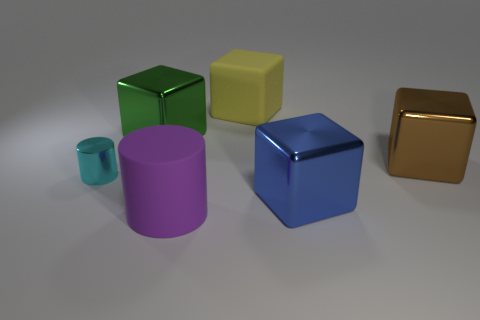Is there anything else that has the same material as the tiny thing?
Give a very brief answer. Yes. Is there a large thing?
Offer a very short reply. Yes. Is the cube to the left of the big yellow object made of the same material as the purple cylinder?
Keep it short and to the point. No. Is there another thing of the same shape as the big yellow matte thing?
Make the answer very short. Yes. Is the number of big blue metal blocks that are in front of the shiny cylinder the same as the number of tiny purple rubber blocks?
Your answer should be very brief. No. The big block left of the large rubber object behind the tiny cyan shiny thing is made of what material?
Provide a short and direct response. Metal. What shape is the tiny object?
Ensure brevity in your answer.  Cylinder. Are there an equal number of large matte cubes that are to the left of the big matte block and shiny cubes on the left side of the purple thing?
Your answer should be very brief. No. Are there more rubber cylinders that are to the left of the green block than small yellow metallic balls?
Your answer should be compact. No. What shape is the purple object that is made of the same material as the yellow object?
Your answer should be very brief. Cylinder. 